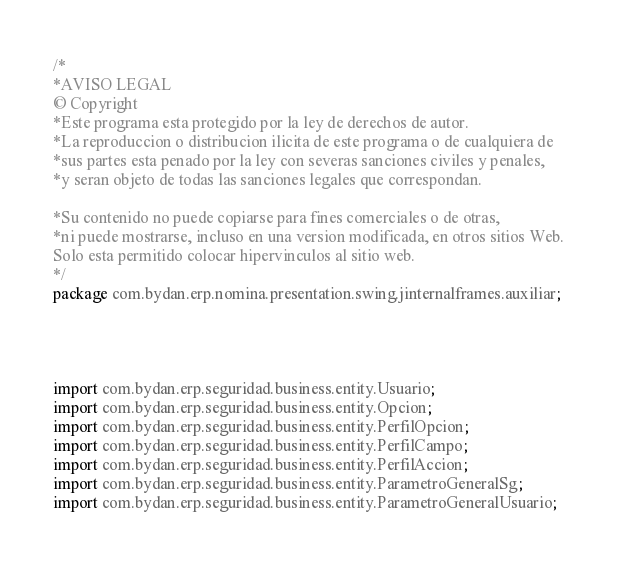<code> <loc_0><loc_0><loc_500><loc_500><_Java_>/*
*AVISO LEGAL
© Copyright
*Este programa esta protegido por la ley de derechos de autor.
*La reproduccion o distribucion ilicita de este programa o de cualquiera de
*sus partes esta penado por la ley con severas sanciones civiles y penales,
*y seran objeto de todas las sanciones legales que correspondan.

*Su contenido no puede copiarse para fines comerciales o de otras,
*ni puede mostrarse, incluso en una version modificada, en otros sitios Web.
Solo esta permitido colocar hipervinculos al sitio web.
*/
package com.bydan.erp.nomina.presentation.swing.jinternalframes.auxiliar;




import com.bydan.erp.seguridad.business.entity.Usuario;
import com.bydan.erp.seguridad.business.entity.Opcion;
import com.bydan.erp.seguridad.business.entity.PerfilOpcion;
import com.bydan.erp.seguridad.business.entity.PerfilCampo;
import com.bydan.erp.seguridad.business.entity.PerfilAccion;
import com.bydan.erp.seguridad.business.entity.ParametroGeneralSg;
import com.bydan.erp.seguridad.business.entity.ParametroGeneralUsuario;</code> 